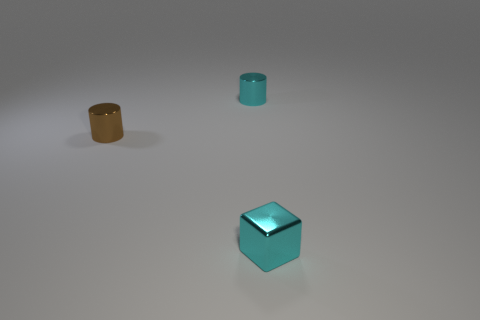Is the surface on which the objects are placed inclined or level? The surface appears to be level as there is no indication of the objects sliding or tilting, which would suggest an incline. 